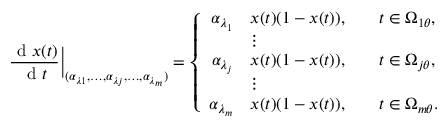Convert formula to latex. <formula><loc_0><loc_0><loc_500><loc_500>\frac { d x ( t ) } { d t } \Big | _ { ( \alpha _ { \lambda 1 } , \dots , \alpha _ { \lambda j } , \dots , \alpha _ { \lambda _ { m } } ) } = \left \{ \begin{array} { r l r l } { \alpha _ { \lambda _ { 1 } } } & { x ( t ) ( 1 - x ( t ) ) , } & & { t \in \Omega _ { 1 \theta } , } \\ & { \vdots } & \\ { \alpha _ { \lambda _ { j } } } & { x ( t ) ( 1 - x ( t ) ) , } & & { t \in \Omega _ { j \theta } , } \\ & { \vdots } & \\ { \alpha _ { \lambda _ { m } } } & { x ( t ) ( 1 - x ( t ) ) , } & & { t \in \Omega _ { m \theta } . } \end{array}</formula> 